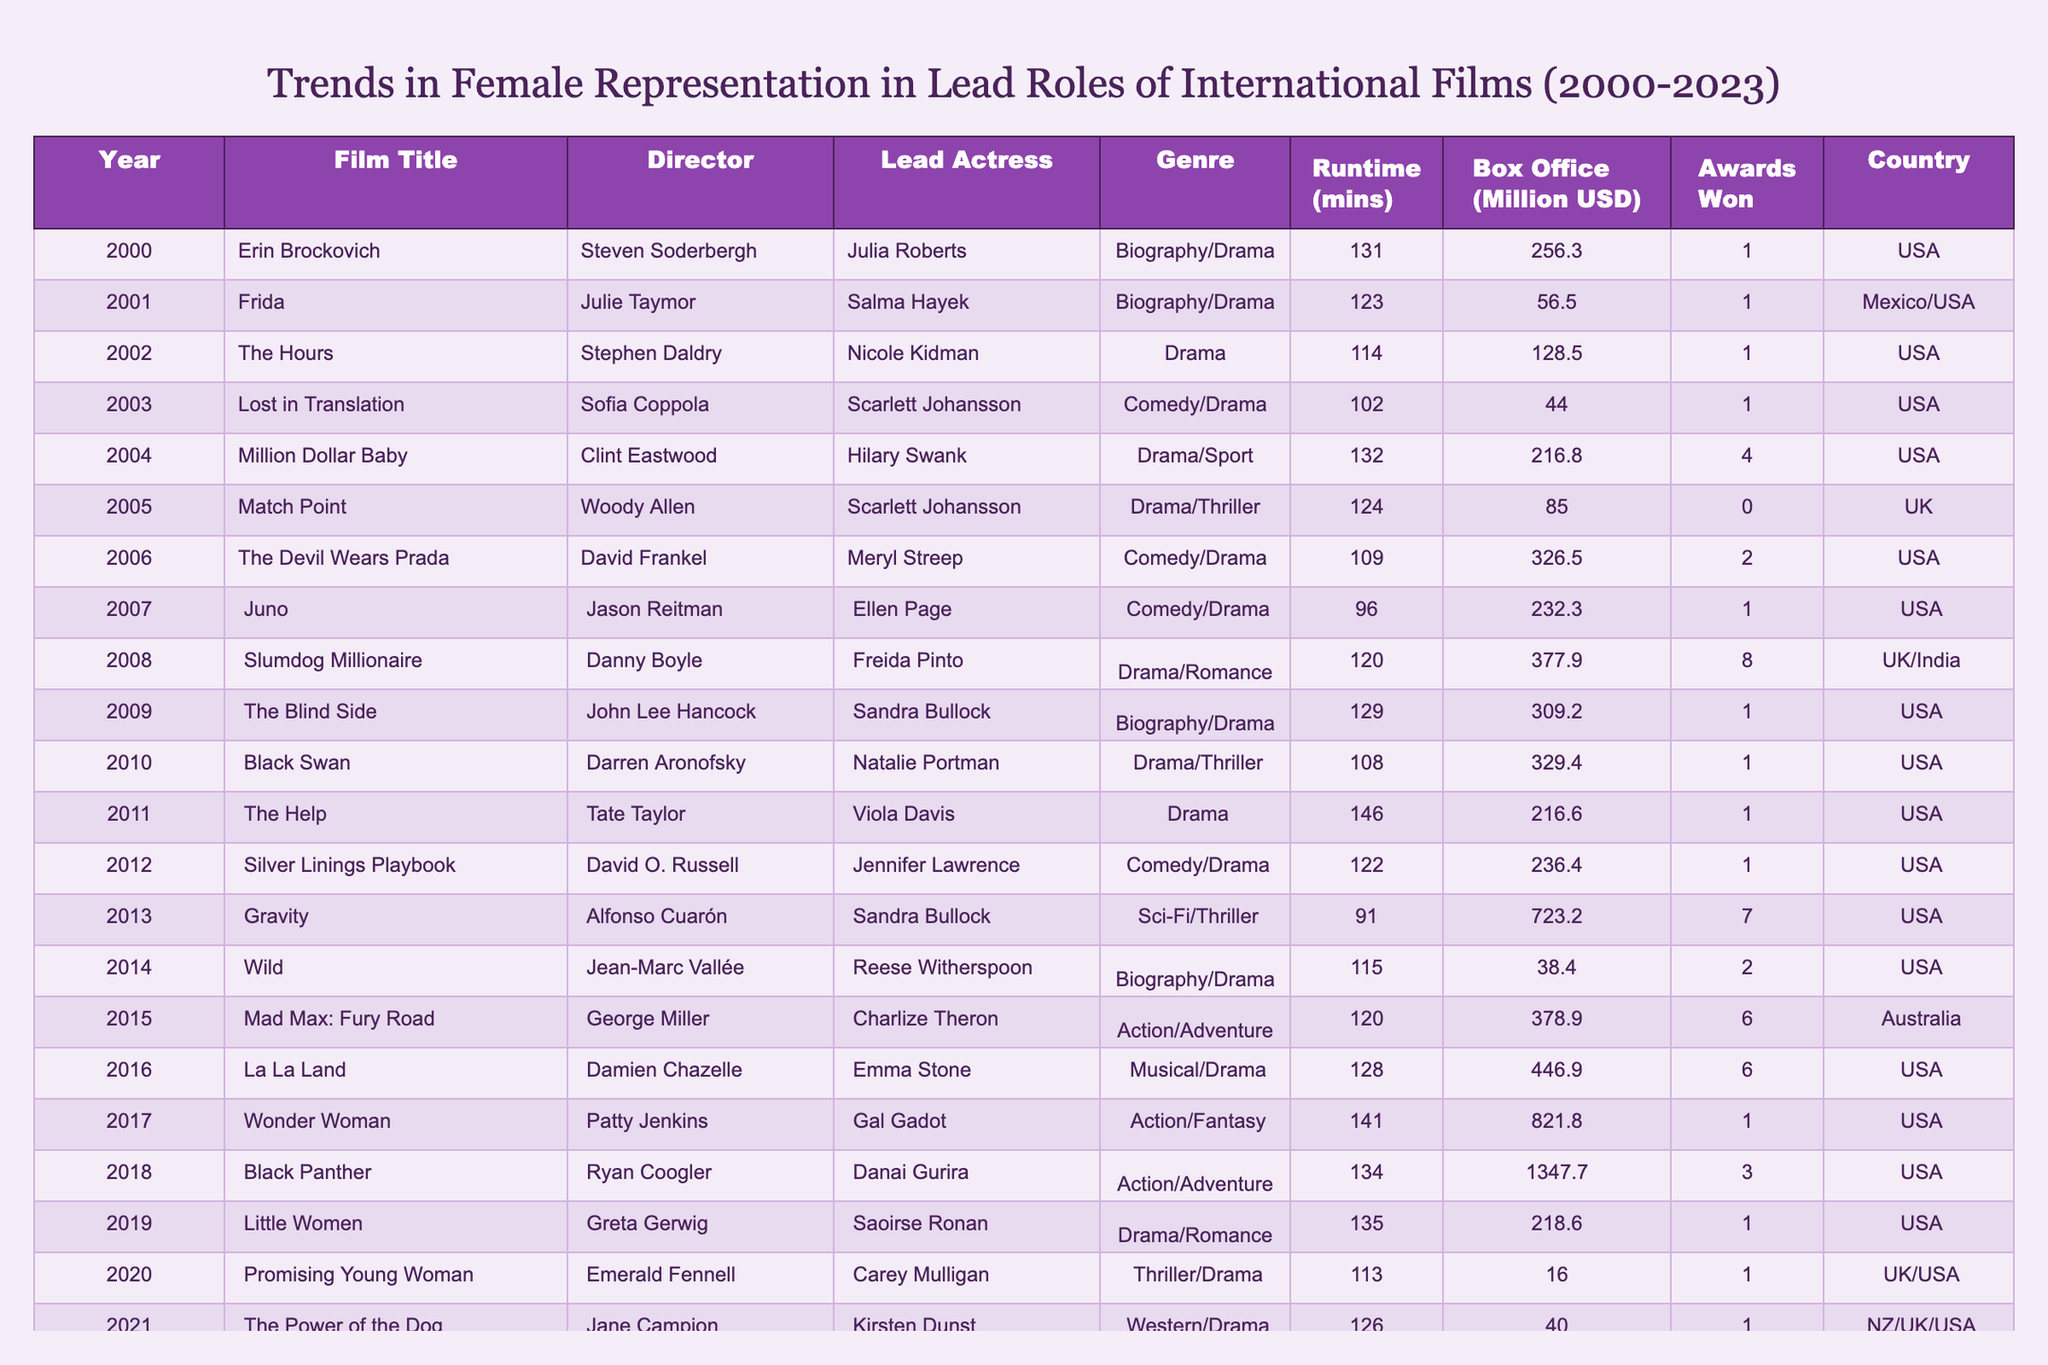What was the highest box office gross for a film with a female lead from 2000 to 2023? The highest box office gross is 1347.7 million USD, which is from the film "Black Panther" in 2018.
Answer: 1347.7 million USD Which film with a female lead won the most awards during this period? "Slumdog Millionaire" won the highest number of awards, totaling 8 awards in 2008.
Answer: 8 awards How many films from the table feature female leads in the action genre? There are 3 films featuring female leads in the action genre: "Mad Max: Fury Road" (2015), "Wonder Woman" (2017), and "Black Panther" (2018).
Answer: 3 films What is the average runtime of all films listed? The total runtime of all films is 2,683 minutes (sum of all runtimes), and there are 23 films, so the average runtime is 2,683/23, which is approximately 116.7 minutes.
Answer: 116.7 minutes Did any film in the table receive no awards despite a female lead? Yes, "Match Point" (2005) did not win any awards despite featuring a female lead.
Answer: Yes What percentage of the films listed are directed by female directors? Out of the 23 films, 4 were directed by women: "Frida," "Juno," "The Help," and "The Power of the Dog." This is approximately 17.4% (4/23 * 100).
Answer: 17.4% How does the box office revenue of "Gravity" compare to "Promising Young Woman"? "Gravity" grossed 723.2 million USD, while "Promising Young Woman" grossed 16 million USD. Thus, "Gravity" earned 707.2 million USD more than "Promising Young Woman."
Answer: 707.2 million USD Which year saw the release of the film with the least box office revenue? The film with the least box office revenue is "Promising Young Woman," which was released in 2020 and grossed 16 million USD.
Answer: 2020 In terms of genre diversity, how many different genres are represented in films with female leads from 2000 to 2023? There are 7 different genres represented, including Biography/Drama, Comedy/Drama, Drama, Drama/Sport, Action/Adventure, Sci-Fi/Thriller, and Musical/Drama.
Answer: 7 genres Which lead actress appears in more than one film in the table? Scarlett Johansson appears in two films: "Lost in Translation" (2003) and "Match Point" (2005).
Answer: Scarlett Johansson What was the runtime difference between "The Devil Wears Prada" and "Wild"? "The Devil Wears Prada" has a runtime of 109 minutes, and "Wild" has a runtime of 115 minutes. Thus, the difference is 115 - 109 = 6 minutes.
Answer: 6 minutes 